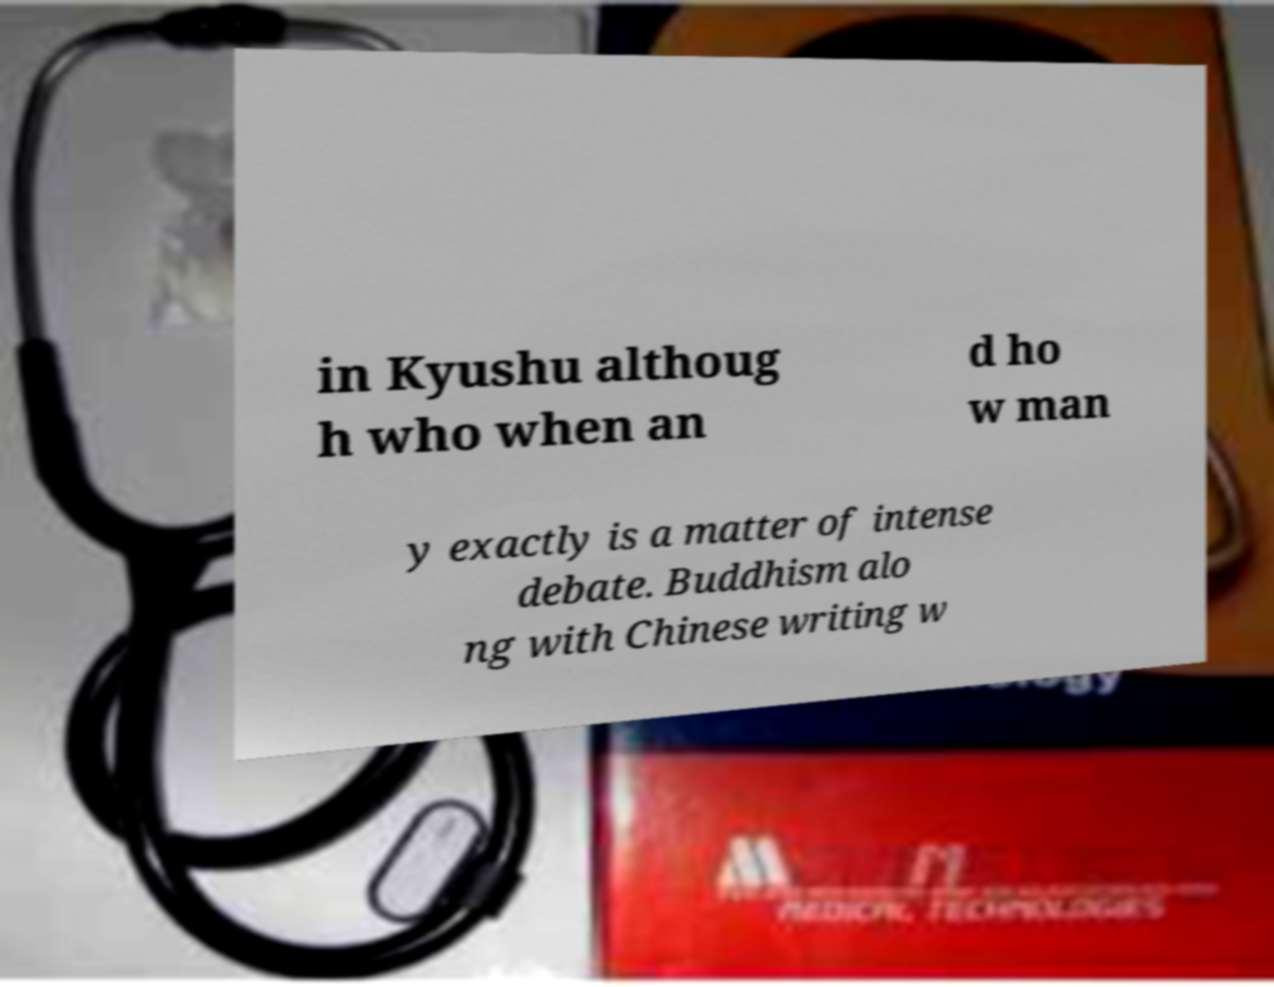Please read and relay the text visible in this image. What does it say? in Kyushu althoug h who when an d ho w man y exactly is a matter of intense debate. Buddhism alo ng with Chinese writing w 